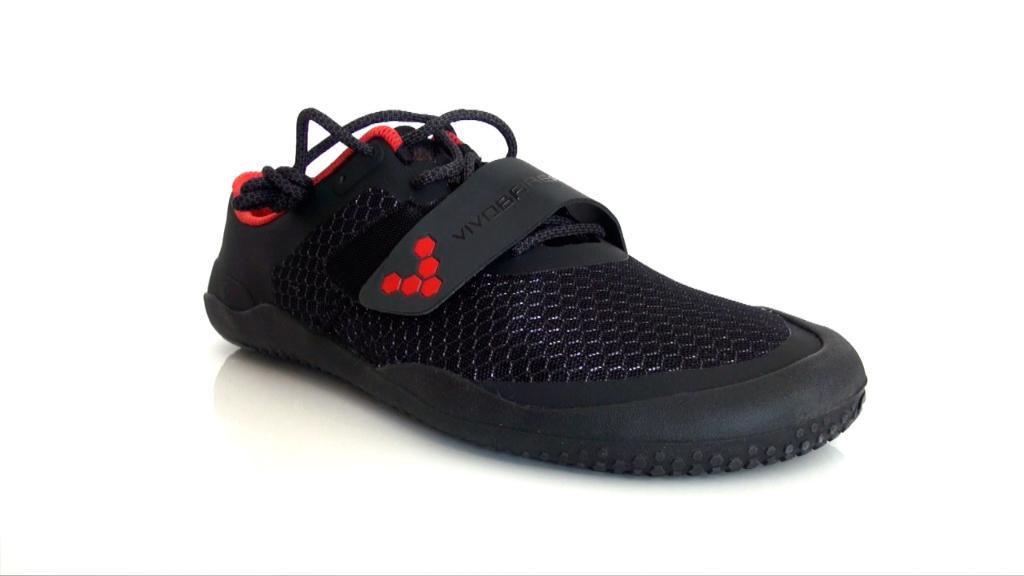What object is in the image? There is a shoe in the image. What feature does the shoe have? The shoe has laces. On what surface is the shoe placed? The shoe is placed on a white surface. What type of voice can be heard coming from the governor in the image? There is no governor or voice present in the image; it only features a shoe with laces on a white surface. 